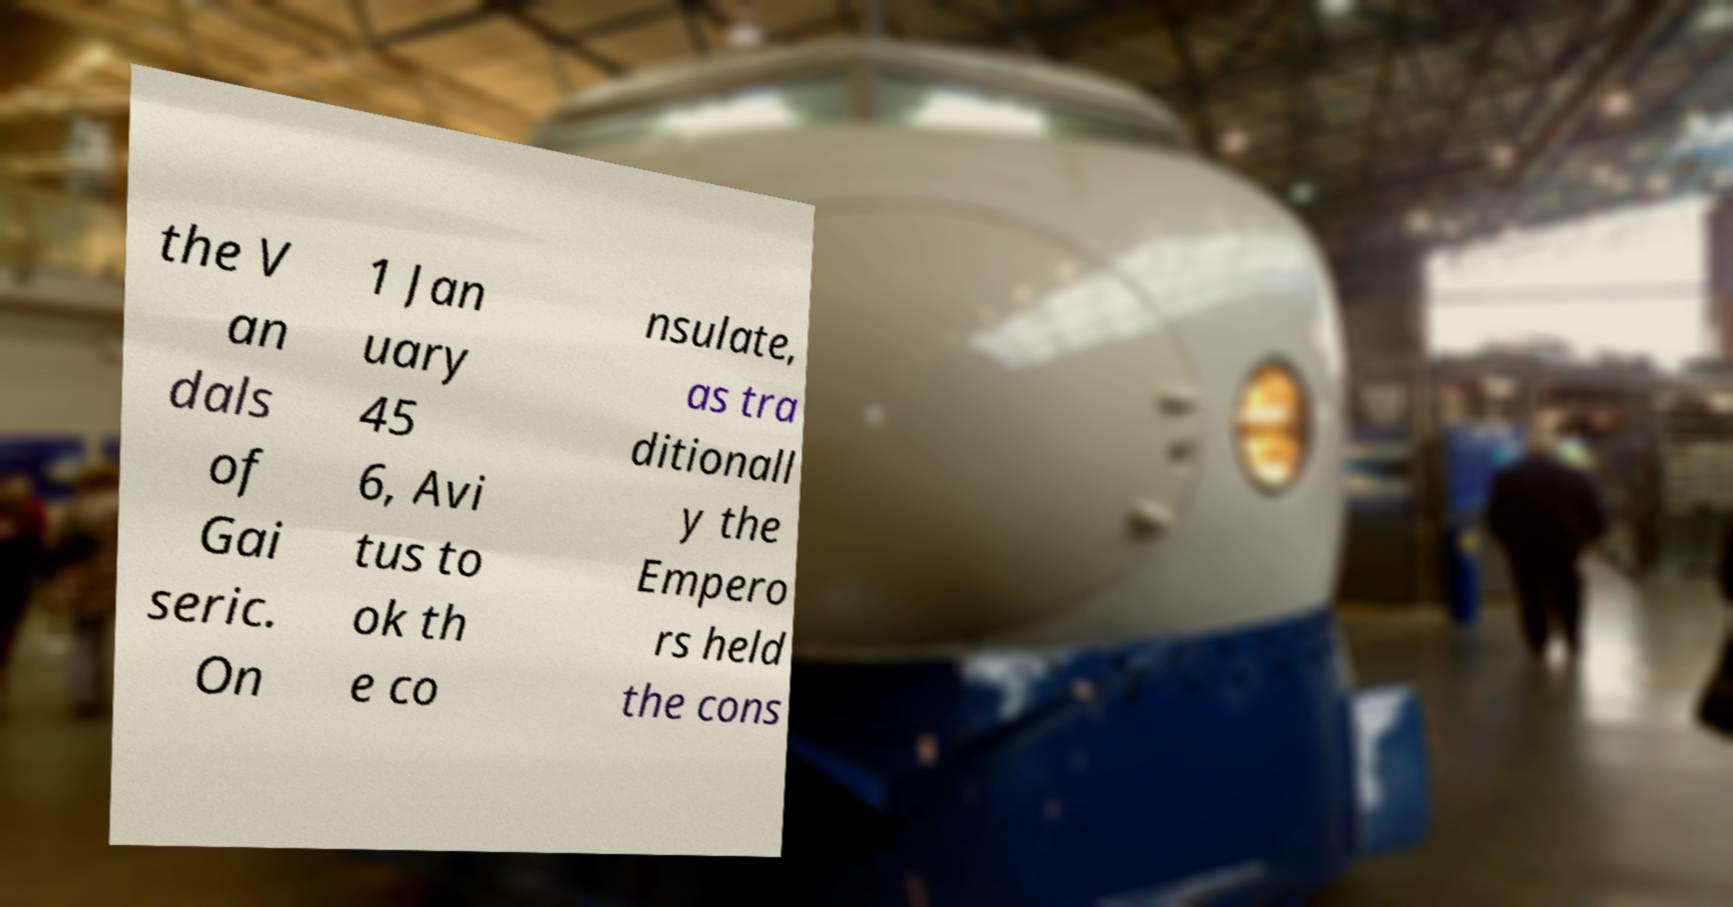Can you read and provide the text displayed in the image?This photo seems to have some interesting text. Can you extract and type it out for me? the V an dals of Gai seric. On 1 Jan uary 45 6, Avi tus to ok th e co nsulate, as tra ditionall y the Empero rs held the cons 